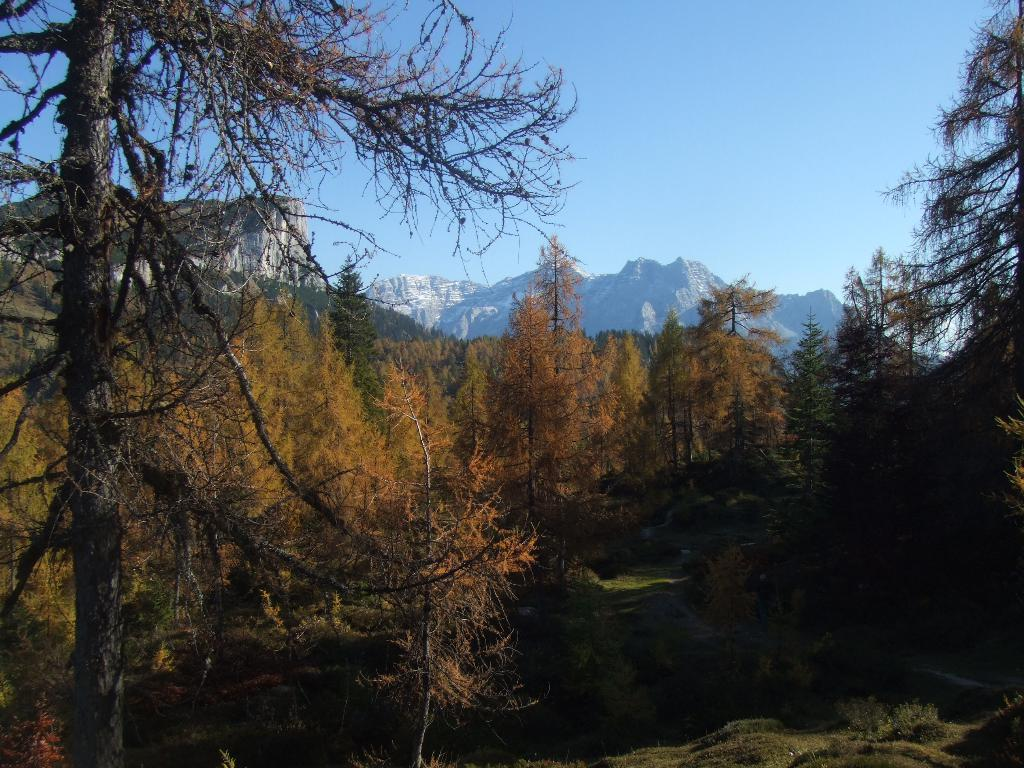What type of vegetation can be seen in the image? There are trees in the image. What is the color of the trees? The trees are green in color. What can be seen in the distance behind the trees? There are mountains visible in the background of the image. What is the color of the sky in the image? The sky is blue in color. How does the society in the image use the comb to prevent loss? There is no society, comb, or loss present in the image; it features trees, mountains, and a blue sky. 